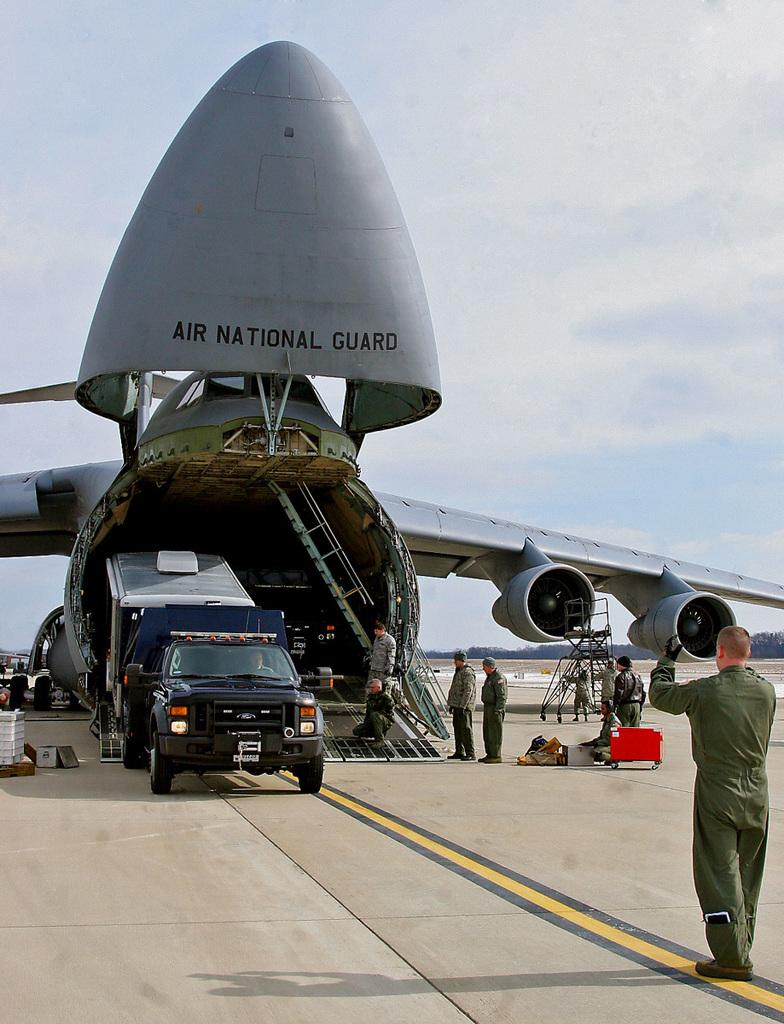<image>
Summarize the visual content of the image. An Air national Guard airplane has a truck coming out of it. 